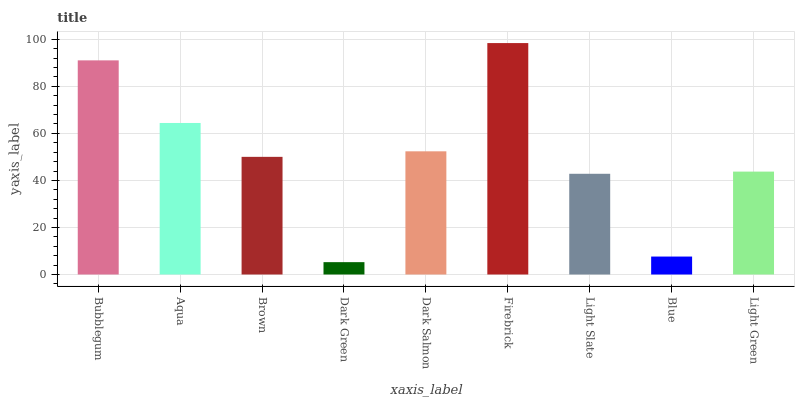Is Dark Green the minimum?
Answer yes or no. Yes. Is Firebrick the maximum?
Answer yes or no. Yes. Is Aqua the minimum?
Answer yes or no. No. Is Aqua the maximum?
Answer yes or no. No. Is Bubblegum greater than Aqua?
Answer yes or no. Yes. Is Aqua less than Bubblegum?
Answer yes or no. Yes. Is Aqua greater than Bubblegum?
Answer yes or no. No. Is Bubblegum less than Aqua?
Answer yes or no. No. Is Brown the high median?
Answer yes or no. Yes. Is Brown the low median?
Answer yes or no. Yes. Is Dark Green the high median?
Answer yes or no. No. Is Dark Salmon the low median?
Answer yes or no. No. 